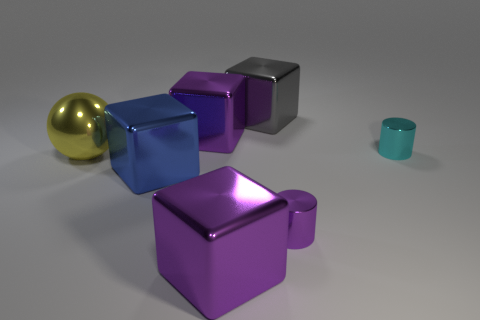How many small things are blue things or purple shiny things?
Provide a succinct answer. 1. There is a yellow metallic object that is the same size as the gray thing; what is its shape?
Offer a terse response. Sphere. Does the metallic cube in front of the blue shiny object have the same color as the large ball?
Your response must be concise. No. How many objects are metallic cylinders behind the blue thing or small cyan metal things?
Your answer should be compact. 1. Is the number of small cylinders in front of the tiny cyan metallic cylinder greater than the number of big balls in front of the yellow shiny object?
Your response must be concise. Yes. What is the shape of the thing that is right of the gray metal block and left of the small cyan cylinder?
Provide a short and direct response. Cylinder. There is a tiny purple object that is the same material as the yellow sphere; what is its shape?
Your response must be concise. Cylinder. Are any blue rubber objects visible?
Your response must be concise. No. Is there a big metal thing behind the small shiny cylinder in front of the large yellow metal ball?
Give a very brief answer. Yes. There is a big gray thing that is the same shape as the blue thing; what material is it?
Your answer should be compact. Metal. 